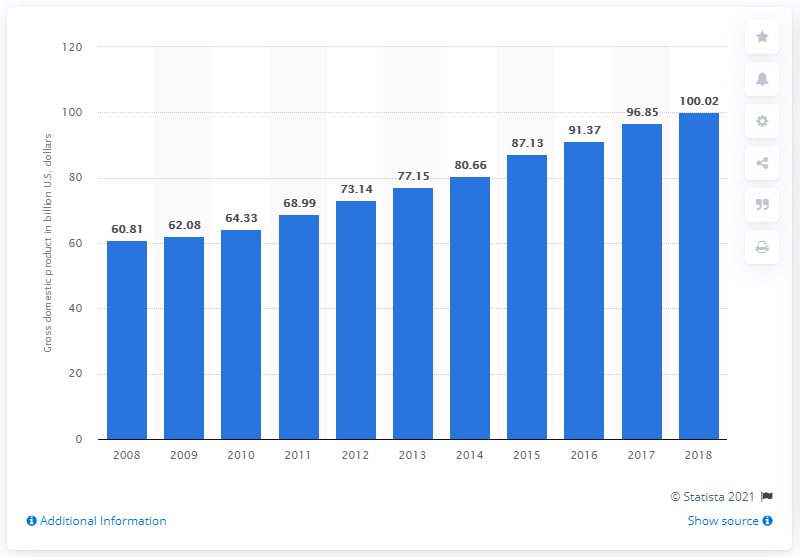Specify some key components in this picture. In 2018, Cuba's gross domestic product was approximately $100.02 billion in dollars. 